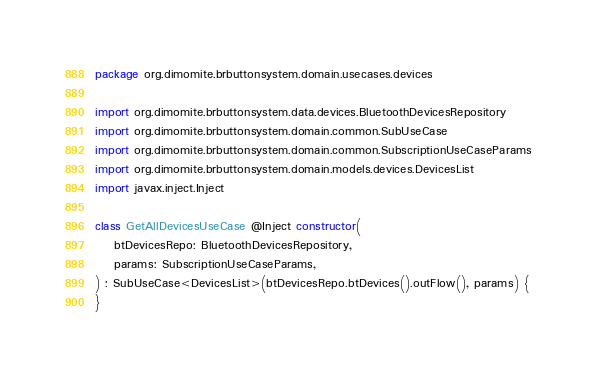<code> <loc_0><loc_0><loc_500><loc_500><_Kotlin_>package org.dimomite.brbuttonsystem.domain.usecases.devices

import org.dimomite.brbuttonsystem.data.devices.BluetoothDevicesRepository
import org.dimomite.brbuttonsystem.domain.common.SubUseCase
import org.dimomite.brbuttonsystem.domain.common.SubscriptionUseCaseParams
import org.dimomite.brbuttonsystem.domain.models.devices.DevicesList
import javax.inject.Inject

class GetAllDevicesUseCase @Inject constructor(
    btDevicesRepo: BluetoothDevicesRepository,
    params: SubscriptionUseCaseParams,
) : SubUseCase<DevicesList>(btDevicesRepo.btDevices().outFlow(), params) {
}</code> 